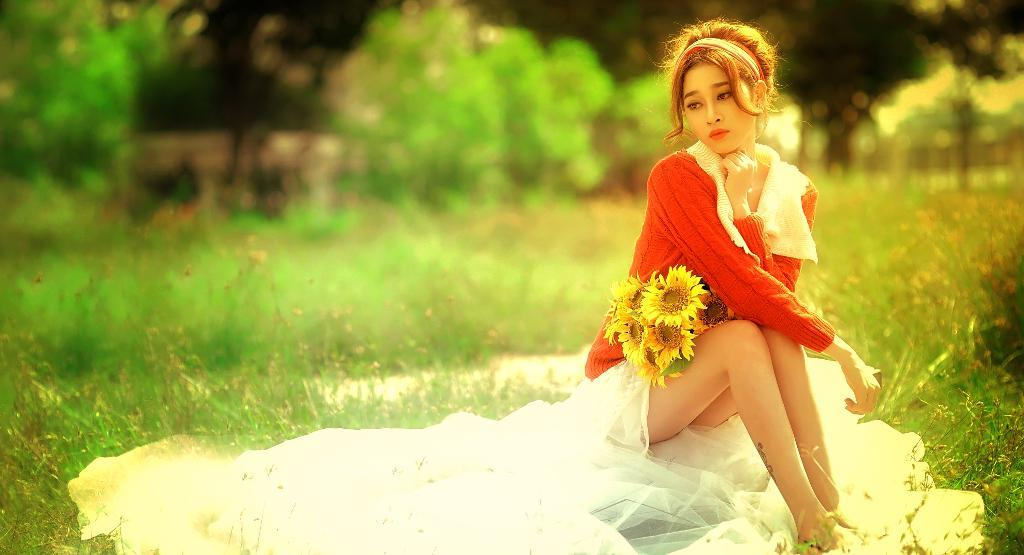What is the person in the image doing? The person is sitting on the grass. What is the person holding or interacting with in the image? The person has flowers on her lap. Can you describe the background of the image? The background of the image is blurry. What is the value of the drain in the image? There is no drain present in the image, so it is not possible to determine its value. 